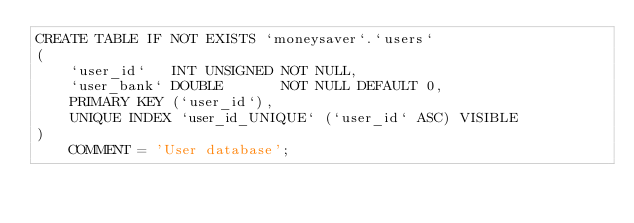<code> <loc_0><loc_0><loc_500><loc_500><_SQL_>CREATE TABLE IF NOT EXISTS `moneysaver`.`users`
(
    `user_id`   INT UNSIGNED NOT NULL,
    `user_bank` DOUBLE       NOT NULL DEFAULT 0,
    PRIMARY KEY (`user_id`),
    UNIQUE INDEX `user_id_UNIQUE` (`user_id` ASC) VISIBLE
)
    COMMENT = 'User database';</code> 